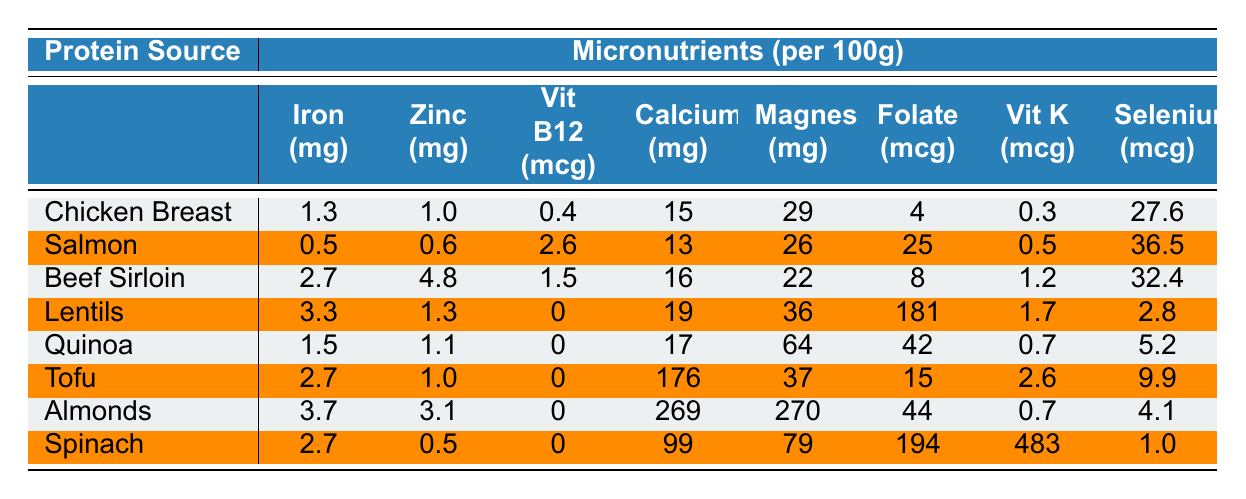What is the highest iron content among the protein sources listed? By examining the "Iron (mg)" column, the highest value is 3.7 mg found in Almonds.
Answer: 3.7 mg Which protein source has the highest vitamin B12 content? Looking at the "Vit B12 (mcg)" column, Salmon has the highest value at 2.6 mcg.
Answer: Salmon, 2.6 mcg What is the calcium content difference between Chicken Breast and Spinach? For Chicken Breast, the calcium content is 15 mg, and for Spinach, it is 99 mg. The difference is 99 - 15 = 84 mg.
Answer: 84 mg Do any plant-based protein sources contain vitamin B12? By checking the "Vit B12 (mcg)" column for plant-based sources like Lentils, Quinoa, Tofu, Almonds, and Spinach, all show 0 mcg for vitamin B12. Thus, no plant-based protein sources contain it.
Answer: No Which has a higher magnesium content: Tofu or Salmon? Tofu has 37 mg of magnesium while Salmon has 26 mg. Since 37 is greater than 26, Tofu has a higher magnesium content.
Answer: Tofu What is the total folate content in Lentils, Quinoa, and Spinach combined? The folate contents are 181 mcg (Lentils) + 42 mcg (Quinoa) + 194 mcg (Spinach). Summing these gives 417 mcg.
Answer: 417 mcg Is the selenium content in Beef Sirloin greater than that in Lentils? Beef Sirloin has 32.4 mcg of selenium, while Lentils have 2.8 mcg. Since 32.4 is greater than 2.8, the answer is yes.
Answer: Yes What is the average zinc content across all protein sources? Adding all the zinc values: (1.0 + 0.6 + 4.8 + 1.3 + 1.1 + 1.0 + 3.1 + 0.5) = 13.4 mg and dividing by 8 gives 1.675 mg as the average.
Answer: 1.675 mg Which protein source has the highest calcium content? By examining the "Calcium (mg)" column, Almonds have the highest value at 269 mg.
Answer: Almonds, 269 mg If you compare the vitamin K content, which protein source has the least? Looking at the "Vit K (mcg)" column, Lentils have the lowest content at 1.7 mcg when compared with other protein sources.
Answer: Lentils, 1.7 mcg 